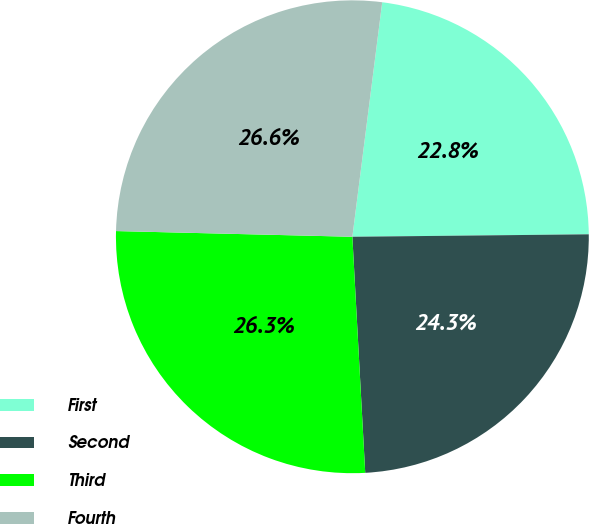Convert chart to OTSL. <chart><loc_0><loc_0><loc_500><loc_500><pie_chart><fcel>First<fcel>Second<fcel>Third<fcel>Fourth<nl><fcel>22.82%<fcel>24.3%<fcel>26.25%<fcel>26.63%<nl></chart> 